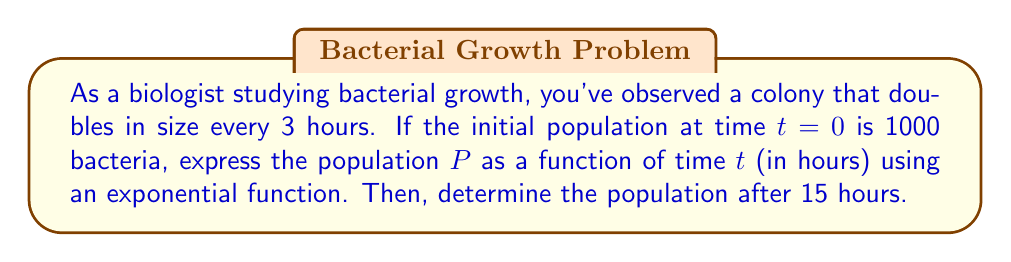Show me your answer to this math problem. Let's approach this step-by-step:

1) The general form of an exponential growth function is:

   $$P(t) = P_0 \cdot b^{t/k}$$

   Where:
   $P(t)$ is the population at time $t$
   $P_0$ is the initial population
   $b$ is the growth factor per unit time
   $k$ is the time it takes for one doubling to occur

2) We know:
   $P_0 = 1000$
   $k = 3$ hours (doubling time)
   $b = 2$ (population doubles each time period)

3) Substituting these values into our equation:

   $$P(t) = 1000 \cdot 2^{t/3}$$

4) To find the population after 15 hours, we substitute $t = 15$:

   $$P(15) = 1000 \cdot 2^{15/3}$$
   $$= 1000 \cdot 2^5$$
   $$= 1000 \cdot 32$$
   $$= 32000$$

5) We can verify this result:
   After 3 hours: 2000 bacteria
   After 6 hours: 4000 bacteria
   After 9 hours: 8000 bacteria
   After 12 hours: 16000 bacteria
   After 15 hours: 32000 bacteria

This exponential growth can be visualized on a coordinate system with time on the x-axis and population on the y-axis, showing the characteristic curve of exponential growth.
Answer: The population $P$ as a function of time $t$ (in hours) is:

$$P(t) = 1000 \cdot 2^{t/3}$$

The population after 15 hours is 32000 bacteria. 